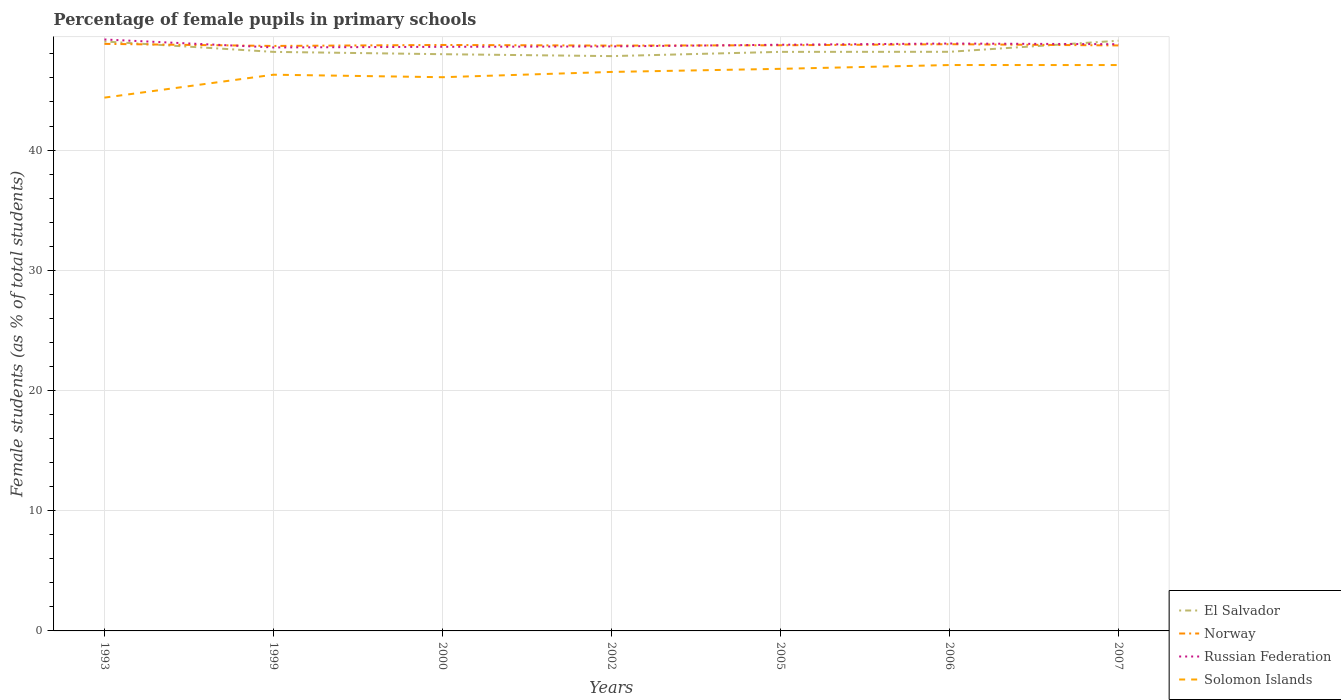How many different coloured lines are there?
Provide a short and direct response. 4. Is the number of lines equal to the number of legend labels?
Keep it short and to the point. Yes. Across all years, what is the maximum percentage of female pupils in primary schools in Norway?
Provide a short and direct response. 48.66. What is the total percentage of female pupils in primary schools in El Salvador in the graph?
Ensure brevity in your answer.  -0.93. What is the difference between the highest and the second highest percentage of female pupils in primary schools in Russian Federation?
Make the answer very short. 0.66. What is the difference between the highest and the lowest percentage of female pupils in primary schools in Norway?
Offer a very short reply. 3. Is the percentage of female pupils in primary schools in El Salvador strictly greater than the percentage of female pupils in primary schools in Russian Federation over the years?
Make the answer very short. No. How many years are there in the graph?
Your answer should be compact. 7. What is the difference between two consecutive major ticks on the Y-axis?
Your answer should be compact. 10. Are the values on the major ticks of Y-axis written in scientific E-notation?
Offer a very short reply. No. Does the graph contain grids?
Offer a very short reply. Yes. Where does the legend appear in the graph?
Provide a short and direct response. Bottom right. How many legend labels are there?
Offer a very short reply. 4. How are the legend labels stacked?
Your answer should be compact. Vertical. What is the title of the graph?
Offer a terse response. Percentage of female pupils in primary schools. What is the label or title of the Y-axis?
Offer a terse response. Female students (as % of total students). What is the Female students (as % of total students) in El Salvador in 1993?
Keep it short and to the point. 49.03. What is the Female students (as % of total students) in Norway in 1993?
Your answer should be compact. 48.83. What is the Female students (as % of total students) of Russian Federation in 1993?
Offer a terse response. 49.2. What is the Female students (as % of total students) of Solomon Islands in 1993?
Ensure brevity in your answer.  44.36. What is the Female students (as % of total students) of El Salvador in 1999?
Ensure brevity in your answer.  48.17. What is the Female students (as % of total students) in Norway in 1999?
Offer a terse response. 48.66. What is the Female students (as % of total students) in Russian Federation in 1999?
Keep it short and to the point. 48.54. What is the Female students (as % of total students) in Solomon Islands in 1999?
Provide a short and direct response. 46.27. What is the Female students (as % of total students) in El Salvador in 2000?
Ensure brevity in your answer.  47.97. What is the Female students (as % of total students) of Norway in 2000?
Your answer should be very brief. 48.74. What is the Female students (as % of total students) of Russian Federation in 2000?
Offer a terse response. 48.59. What is the Female students (as % of total students) in Solomon Islands in 2000?
Provide a short and direct response. 46.06. What is the Female students (as % of total students) in El Salvador in 2002?
Give a very brief answer. 47.82. What is the Female students (as % of total students) in Norway in 2002?
Provide a short and direct response. 48.69. What is the Female students (as % of total students) in Russian Federation in 2002?
Offer a terse response. 48.62. What is the Female students (as % of total students) of Solomon Islands in 2002?
Keep it short and to the point. 46.5. What is the Female students (as % of total students) of El Salvador in 2005?
Ensure brevity in your answer.  48.17. What is the Female students (as % of total students) of Norway in 2005?
Offer a terse response. 48.72. What is the Female students (as % of total students) in Russian Federation in 2005?
Your answer should be very brief. 48.76. What is the Female students (as % of total students) of Solomon Islands in 2005?
Give a very brief answer. 46.76. What is the Female students (as % of total students) in El Salvador in 2006?
Your answer should be very brief. 48.17. What is the Female students (as % of total students) of Norway in 2006?
Your answer should be compact. 48.81. What is the Female students (as % of total students) of Russian Federation in 2006?
Your response must be concise. 48.86. What is the Female students (as % of total students) of Solomon Islands in 2006?
Provide a succinct answer. 47.07. What is the Female students (as % of total students) of El Salvador in 2007?
Make the answer very short. 49.09. What is the Female students (as % of total students) of Norway in 2007?
Your answer should be very brief. 48.7. What is the Female students (as % of total students) of Russian Federation in 2007?
Offer a terse response. 48.81. What is the Female students (as % of total students) in Solomon Islands in 2007?
Your answer should be compact. 47.07. Across all years, what is the maximum Female students (as % of total students) of El Salvador?
Provide a succinct answer. 49.09. Across all years, what is the maximum Female students (as % of total students) in Norway?
Provide a short and direct response. 48.83. Across all years, what is the maximum Female students (as % of total students) of Russian Federation?
Give a very brief answer. 49.2. Across all years, what is the maximum Female students (as % of total students) in Solomon Islands?
Provide a succinct answer. 47.07. Across all years, what is the minimum Female students (as % of total students) in El Salvador?
Ensure brevity in your answer.  47.82. Across all years, what is the minimum Female students (as % of total students) of Norway?
Provide a short and direct response. 48.66. Across all years, what is the minimum Female students (as % of total students) in Russian Federation?
Give a very brief answer. 48.54. Across all years, what is the minimum Female students (as % of total students) of Solomon Islands?
Offer a very short reply. 44.36. What is the total Female students (as % of total students) in El Salvador in the graph?
Make the answer very short. 338.43. What is the total Female students (as % of total students) of Norway in the graph?
Your answer should be very brief. 341.15. What is the total Female students (as % of total students) of Russian Federation in the graph?
Provide a succinct answer. 341.38. What is the total Female students (as % of total students) of Solomon Islands in the graph?
Offer a very short reply. 324.09. What is the difference between the Female students (as % of total students) of El Salvador in 1993 and that in 1999?
Provide a short and direct response. 0.86. What is the difference between the Female students (as % of total students) of Norway in 1993 and that in 1999?
Give a very brief answer. 0.17. What is the difference between the Female students (as % of total students) in Russian Federation in 1993 and that in 1999?
Provide a succinct answer. 0.66. What is the difference between the Female students (as % of total students) of Solomon Islands in 1993 and that in 1999?
Keep it short and to the point. -1.91. What is the difference between the Female students (as % of total students) of El Salvador in 1993 and that in 2000?
Offer a terse response. 1.06. What is the difference between the Female students (as % of total students) of Norway in 1993 and that in 2000?
Keep it short and to the point. 0.09. What is the difference between the Female students (as % of total students) of Russian Federation in 1993 and that in 2000?
Provide a succinct answer. 0.61. What is the difference between the Female students (as % of total students) in Solomon Islands in 1993 and that in 2000?
Offer a very short reply. -1.7. What is the difference between the Female students (as % of total students) in El Salvador in 1993 and that in 2002?
Your answer should be compact. 1.22. What is the difference between the Female students (as % of total students) in Norway in 1993 and that in 2002?
Ensure brevity in your answer.  0.14. What is the difference between the Female students (as % of total students) of Russian Federation in 1993 and that in 2002?
Your response must be concise. 0.58. What is the difference between the Female students (as % of total students) in Solomon Islands in 1993 and that in 2002?
Make the answer very short. -2.14. What is the difference between the Female students (as % of total students) of El Salvador in 1993 and that in 2005?
Offer a very short reply. 0.86. What is the difference between the Female students (as % of total students) in Norway in 1993 and that in 2005?
Offer a terse response. 0.12. What is the difference between the Female students (as % of total students) of Russian Federation in 1993 and that in 2005?
Offer a very short reply. 0.44. What is the difference between the Female students (as % of total students) in Solomon Islands in 1993 and that in 2005?
Your answer should be very brief. -2.4. What is the difference between the Female students (as % of total students) of El Salvador in 1993 and that in 2006?
Provide a short and direct response. 0.86. What is the difference between the Female students (as % of total students) of Norway in 1993 and that in 2006?
Offer a very short reply. 0.03. What is the difference between the Female students (as % of total students) of Russian Federation in 1993 and that in 2006?
Keep it short and to the point. 0.34. What is the difference between the Female students (as % of total students) of Solomon Islands in 1993 and that in 2006?
Provide a short and direct response. -2.71. What is the difference between the Female students (as % of total students) in El Salvador in 1993 and that in 2007?
Give a very brief answer. -0.06. What is the difference between the Female students (as % of total students) in Norway in 1993 and that in 2007?
Your answer should be compact. 0.13. What is the difference between the Female students (as % of total students) in Russian Federation in 1993 and that in 2007?
Your answer should be compact. 0.39. What is the difference between the Female students (as % of total students) in Solomon Islands in 1993 and that in 2007?
Your answer should be compact. -2.71. What is the difference between the Female students (as % of total students) of El Salvador in 1999 and that in 2000?
Your answer should be compact. 0.19. What is the difference between the Female students (as % of total students) in Norway in 1999 and that in 2000?
Make the answer very short. -0.08. What is the difference between the Female students (as % of total students) in Russian Federation in 1999 and that in 2000?
Your answer should be very brief. -0.05. What is the difference between the Female students (as % of total students) in Solomon Islands in 1999 and that in 2000?
Your response must be concise. 0.21. What is the difference between the Female students (as % of total students) in El Salvador in 1999 and that in 2002?
Your response must be concise. 0.35. What is the difference between the Female students (as % of total students) in Norway in 1999 and that in 2002?
Your response must be concise. -0.03. What is the difference between the Female students (as % of total students) of Russian Federation in 1999 and that in 2002?
Offer a terse response. -0.09. What is the difference between the Female students (as % of total students) of Solomon Islands in 1999 and that in 2002?
Keep it short and to the point. -0.23. What is the difference between the Female students (as % of total students) in El Salvador in 1999 and that in 2005?
Offer a terse response. -0. What is the difference between the Female students (as % of total students) in Norway in 1999 and that in 2005?
Make the answer very short. -0.05. What is the difference between the Female students (as % of total students) in Russian Federation in 1999 and that in 2005?
Provide a short and direct response. -0.22. What is the difference between the Female students (as % of total students) in Solomon Islands in 1999 and that in 2005?
Your answer should be compact. -0.49. What is the difference between the Female students (as % of total students) of El Salvador in 1999 and that in 2006?
Keep it short and to the point. -0.01. What is the difference between the Female students (as % of total students) in Norway in 1999 and that in 2006?
Provide a short and direct response. -0.14. What is the difference between the Female students (as % of total students) of Russian Federation in 1999 and that in 2006?
Provide a succinct answer. -0.33. What is the difference between the Female students (as % of total students) in Solomon Islands in 1999 and that in 2006?
Your answer should be very brief. -0.8. What is the difference between the Female students (as % of total students) of El Salvador in 1999 and that in 2007?
Your answer should be compact. -0.93. What is the difference between the Female students (as % of total students) in Norway in 1999 and that in 2007?
Your answer should be compact. -0.04. What is the difference between the Female students (as % of total students) of Russian Federation in 1999 and that in 2007?
Your answer should be compact. -0.27. What is the difference between the Female students (as % of total students) in Solomon Islands in 1999 and that in 2007?
Your answer should be very brief. -0.8. What is the difference between the Female students (as % of total students) of El Salvador in 2000 and that in 2002?
Ensure brevity in your answer.  0.16. What is the difference between the Female students (as % of total students) of Norway in 2000 and that in 2002?
Give a very brief answer. 0.05. What is the difference between the Female students (as % of total students) in Russian Federation in 2000 and that in 2002?
Offer a very short reply. -0.03. What is the difference between the Female students (as % of total students) of Solomon Islands in 2000 and that in 2002?
Provide a short and direct response. -0.44. What is the difference between the Female students (as % of total students) in El Salvador in 2000 and that in 2005?
Make the answer very short. -0.19. What is the difference between the Female students (as % of total students) of Norway in 2000 and that in 2005?
Give a very brief answer. 0.03. What is the difference between the Female students (as % of total students) of Russian Federation in 2000 and that in 2005?
Your response must be concise. -0.17. What is the difference between the Female students (as % of total students) in Solomon Islands in 2000 and that in 2005?
Offer a terse response. -0.7. What is the difference between the Female students (as % of total students) in El Salvador in 2000 and that in 2006?
Give a very brief answer. -0.2. What is the difference between the Female students (as % of total students) in Norway in 2000 and that in 2006?
Make the answer very short. -0.06. What is the difference between the Female students (as % of total students) of Russian Federation in 2000 and that in 2006?
Offer a very short reply. -0.27. What is the difference between the Female students (as % of total students) in Solomon Islands in 2000 and that in 2006?
Offer a very short reply. -1.01. What is the difference between the Female students (as % of total students) in El Salvador in 2000 and that in 2007?
Ensure brevity in your answer.  -1.12. What is the difference between the Female students (as % of total students) in Norway in 2000 and that in 2007?
Make the answer very short. 0.04. What is the difference between the Female students (as % of total students) of Russian Federation in 2000 and that in 2007?
Provide a short and direct response. -0.22. What is the difference between the Female students (as % of total students) of Solomon Islands in 2000 and that in 2007?
Provide a short and direct response. -1.01. What is the difference between the Female students (as % of total students) in El Salvador in 2002 and that in 2005?
Your answer should be very brief. -0.35. What is the difference between the Female students (as % of total students) in Norway in 2002 and that in 2005?
Your response must be concise. -0.03. What is the difference between the Female students (as % of total students) in Russian Federation in 2002 and that in 2005?
Your answer should be very brief. -0.14. What is the difference between the Female students (as % of total students) of Solomon Islands in 2002 and that in 2005?
Give a very brief answer. -0.26. What is the difference between the Female students (as % of total students) in El Salvador in 2002 and that in 2006?
Offer a very short reply. -0.36. What is the difference between the Female students (as % of total students) in Norway in 2002 and that in 2006?
Provide a short and direct response. -0.11. What is the difference between the Female students (as % of total students) in Russian Federation in 2002 and that in 2006?
Make the answer very short. -0.24. What is the difference between the Female students (as % of total students) of Solomon Islands in 2002 and that in 2006?
Your answer should be compact. -0.57. What is the difference between the Female students (as % of total students) in El Salvador in 2002 and that in 2007?
Your answer should be compact. -1.28. What is the difference between the Female students (as % of total students) in Norway in 2002 and that in 2007?
Keep it short and to the point. -0.01. What is the difference between the Female students (as % of total students) in Russian Federation in 2002 and that in 2007?
Offer a terse response. -0.18. What is the difference between the Female students (as % of total students) of Solomon Islands in 2002 and that in 2007?
Provide a short and direct response. -0.57. What is the difference between the Female students (as % of total students) in El Salvador in 2005 and that in 2006?
Provide a succinct answer. -0. What is the difference between the Female students (as % of total students) in Norway in 2005 and that in 2006?
Give a very brief answer. -0.09. What is the difference between the Female students (as % of total students) of Russian Federation in 2005 and that in 2006?
Give a very brief answer. -0.1. What is the difference between the Female students (as % of total students) in Solomon Islands in 2005 and that in 2006?
Offer a very short reply. -0.32. What is the difference between the Female students (as % of total students) in El Salvador in 2005 and that in 2007?
Your answer should be very brief. -0.93. What is the difference between the Female students (as % of total students) of Norway in 2005 and that in 2007?
Make the answer very short. 0.01. What is the difference between the Female students (as % of total students) in Russian Federation in 2005 and that in 2007?
Make the answer very short. -0.05. What is the difference between the Female students (as % of total students) of Solomon Islands in 2005 and that in 2007?
Your answer should be very brief. -0.32. What is the difference between the Female students (as % of total students) in El Salvador in 2006 and that in 2007?
Offer a very short reply. -0.92. What is the difference between the Female students (as % of total students) of Norway in 2006 and that in 2007?
Your answer should be compact. 0.1. What is the difference between the Female students (as % of total students) in Russian Federation in 2006 and that in 2007?
Offer a terse response. 0.06. What is the difference between the Female students (as % of total students) in Solomon Islands in 2006 and that in 2007?
Offer a terse response. 0. What is the difference between the Female students (as % of total students) in El Salvador in 1993 and the Female students (as % of total students) in Norway in 1999?
Offer a very short reply. 0.37. What is the difference between the Female students (as % of total students) of El Salvador in 1993 and the Female students (as % of total students) of Russian Federation in 1999?
Provide a short and direct response. 0.5. What is the difference between the Female students (as % of total students) of El Salvador in 1993 and the Female students (as % of total students) of Solomon Islands in 1999?
Offer a terse response. 2.76. What is the difference between the Female students (as % of total students) of Norway in 1993 and the Female students (as % of total students) of Russian Federation in 1999?
Keep it short and to the point. 0.3. What is the difference between the Female students (as % of total students) in Norway in 1993 and the Female students (as % of total students) in Solomon Islands in 1999?
Make the answer very short. 2.57. What is the difference between the Female students (as % of total students) of Russian Federation in 1993 and the Female students (as % of total students) of Solomon Islands in 1999?
Offer a terse response. 2.93. What is the difference between the Female students (as % of total students) of El Salvador in 1993 and the Female students (as % of total students) of Norway in 2000?
Your answer should be compact. 0.29. What is the difference between the Female students (as % of total students) in El Salvador in 1993 and the Female students (as % of total students) in Russian Federation in 2000?
Your answer should be compact. 0.44. What is the difference between the Female students (as % of total students) of El Salvador in 1993 and the Female students (as % of total students) of Solomon Islands in 2000?
Your answer should be compact. 2.97. What is the difference between the Female students (as % of total students) in Norway in 1993 and the Female students (as % of total students) in Russian Federation in 2000?
Provide a short and direct response. 0.24. What is the difference between the Female students (as % of total students) of Norway in 1993 and the Female students (as % of total students) of Solomon Islands in 2000?
Give a very brief answer. 2.77. What is the difference between the Female students (as % of total students) of Russian Federation in 1993 and the Female students (as % of total students) of Solomon Islands in 2000?
Your answer should be compact. 3.14. What is the difference between the Female students (as % of total students) in El Salvador in 1993 and the Female students (as % of total students) in Norway in 2002?
Offer a terse response. 0.34. What is the difference between the Female students (as % of total students) in El Salvador in 1993 and the Female students (as % of total students) in Russian Federation in 2002?
Your answer should be very brief. 0.41. What is the difference between the Female students (as % of total students) in El Salvador in 1993 and the Female students (as % of total students) in Solomon Islands in 2002?
Your response must be concise. 2.53. What is the difference between the Female students (as % of total students) of Norway in 1993 and the Female students (as % of total students) of Russian Federation in 2002?
Ensure brevity in your answer.  0.21. What is the difference between the Female students (as % of total students) of Norway in 1993 and the Female students (as % of total students) of Solomon Islands in 2002?
Ensure brevity in your answer.  2.33. What is the difference between the Female students (as % of total students) of Russian Federation in 1993 and the Female students (as % of total students) of Solomon Islands in 2002?
Make the answer very short. 2.7. What is the difference between the Female students (as % of total students) in El Salvador in 1993 and the Female students (as % of total students) in Norway in 2005?
Provide a short and direct response. 0.32. What is the difference between the Female students (as % of total students) of El Salvador in 1993 and the Female students (as % of total students) of Russian Federation in 2005?
Make the answer very short. 0.27. What is the difference between the Female students (as % of total students) in El Salvador in 1993 and the Female students (as % of total students) in Solomon Islands in 2005?
Provide a succinct answer. 2.27. What is the difference between the Female students (as % of total students) in Norway in 1993 and the Female students (as % of total students) in Russian Federation in 2005?
Your answer should be very brief. 0.07. What is the difference between the Female students (as % of total students) in Norway in 1993 and the Female students (as % of total students) in Solomon Islands in 2005?
Give a very brief answer. 2.08. What is the difference between the Female students (as % of total students) in Russian Federation in 1993 and the Female students (as % of total students) in Solomon Islands in 2005?
Your answer should be very brief. 2.44. What is the difference between the Female students (as % of total students) in El Salvador in 1993 and the Female students (as % of total students) in Norway in 2006?
Provide a succinct answer. 0.23. What is the difference between the Female students (as % of total students) in El Salvador in 1993 and the Female students (as % of total students) in Russian Federation in 2006?
Provide a succinct answer. 0.17. What is the difference between the Female students (as % of total students) of El Salvador in 1993 and the Female students (as % of total students) of Solomon Islands in 2006?
Your answer should be very brief. 1.96. What is the difference between the Female students (as % of total students) in Norway in 1993 and the Female students (as % of total students) in Russian Federation in 2006?
Provide a succinct answer. -0.03. What is the difference between the Female students (as % of total students) of Norway in 1993 and the Female students (as % of total students) of Solomon Islands in 2006?
Your response must be concise. 1.76. What is the difference between the Female students (as % of total students) of Russian Federation in 1993 and the Female students (as % of total students) of Solomon Islands in 2006?
Offer a very short reply. 2.13. What is the difference between the Female students (as % of total students) of El Salvador in 1993 and the Female students (as % of total students) of Norway in 2007?
Provide a succinct answer. 0.33. What is the difference between the Female students (as % of total students) in El Salvador in 1993 and the Female students (as % of total students) in Russian Federation in 2007?
Give a very brief answer. 0.23. What is the difference between the Female students (as % of total students) of El Salvador in 1993 and the Female students (as % of total students) of Solomon Islands in 2007?
Give a very brief answer. 1.96. What is the difference between the Female students (as % of total students) in Norway in 1993 and the Female students (as % of total students) in Russian Federation in 2007?
Your answer should be very brief. 0.03. What is the difference between the Female students (as % of total students) of Norway in 1993 and the Female students (as % of total students) of Solomon Islands in 2007?
Your answer should be very brief. 1.76. What is the difference between the Female students (as % of total students) in Russian Federation in 1993 and the Female students (as % of total students) in Solomon Islands in 2007?
Give a very brief answer. 2.13. What is the difference between the Female students (as % of total students) in El Salvador in 1999 and the Female students (as % of total students) in Norway in 2000?
Your answer should be very brief. -0.58. What is the difference between the Female students (as % of total students) of El Salvador in 1999 and the Female students (as % of total students) of Russian Federation in 2000?
Ensure brevity in your answer.  -0.42. What is the difference between the Female students (as % of total students) in El Salvador in 1999 and the Female students (as % of total students) in Solomon Islands in 2000?
Offer a terse response. 2.11. What is the difference between the Female students (as % of total students) of Norway in 1999 and the Female students (as % of total students) of Russian Federation in 2000?
Offer a very short reply. 0.07. What is the difference between the Female students (as % of total students) in Norway in 1999 and the Female students (as % of total students) in Solomon Islands in 2000?
Give a very brief answer. 2.6. What is the difference between the Female students (as % of total students) of Russian Federation in 1999 and the Female students (as % of total students) of Solomon Islands in 2000?
Give a very brief answer. 2.48. What is the difference between the Female students (as % of total students) in El Salvador in 1999 and the Female students (as % of total students) in Norway in 2002?
Offer a terse response. -0.52. What is the difference between the Female students (as % of total students) in El Salvador in 1999 and the Female students (as % of total students) in Russian Federation in 2002?
Your response must be concise. -0.45. What is the difference between the Female students (as % of total students) in El Salvador in 1999 and the Female students (as % of total students) in Solomon Islands in 2002?
Provide a short and direct response. 1.67. What is the difference between the Female students (as % of total students) of Norway in 1999 and the Female students (as % of total students) of Russian Federation in 2002?
Keep it short and to the point. 0.04. What is the difference between the Female students (as % of total students) of Norway in 1999 and the Female students (as % of total students) of Solomon Islands in 2002?
Offer a very short reply. 2.16. What is the difference between the Female students (as % of total students) in Russian Federation in 1999 and the Female students (as % of total students) in Solomon Islands in 2002?
Offer a terse response. 2.04. What is the difference between the Female students (as % of total students) in El Salvador in 1999 and the Female students (as % of total students) in Norway in 2005?
Keep it short and to the point. -0.55. What is the difference between the Female students (as % of total students) of El Salvador in 1999 and the Female students (as % of total students) of Russian Federation in 2005?
Offer a very short reply. -0.59. What is the difference between the Female students (as % of total students) in El Salvador in 1999 and the Female students (as % of total students) in Solomon Islands in 2005?
Your answer should be compact. 1.41. What is the difference between the Female students (as % of total students) in Norway in 1999 and the Female students (as % of total students) in Russian Federation in 2005?
Your answer should be compact. -0.1. What is the difference between the Female students (as % of total students) in Norway in 1999 and the Female students (as % of total students) in Solomon Islands in 2005?
Offer a terse response. 1.9. What is the difference between the Female students (as % of total students) of Russian Federation in 1999 and the Female students (as % of total students) of Solomon Islands in 2005?
Your answer should be compact. 1.78. What is the difference between the Female students (as % of total students) in El Salvador in 1999 and the Female students (as % of total students) in Norway in 2006?
Your answer should be very brief. -0.64. What is the difference between the Female students (as % of total students) in El Salvador in 1999 and the Female students (as % of total students) in Russian Federation in 2006?
Offer a very short reply. -0.69. What is the difference between the Female students (as % of total students) in El Salvador in 1999 and the Female students (as % of total students) in Solomon Islands in 2006?
Your answer should be compact. 1.09. What is the difference between the Female students (as % of total students) of Norway in 1999 and the Female students (as % of total students) of Russian Federation in 2006?
Your answer should be compact. -0.2. What is the difference between the Female students (as % of total students) in Norway in 1999 and the Female students (as % of total students) in Solomon Islands in 2006?
Your answer should be compact. 1.59. What is the difference between the Female students (as % of total students) in Russian Federation in 1999 and the Female students (as % of total students) in Solomon Islands in 2006?
Give a very brief answer. 1.46. What is the difference between the Female students (as % of total students) in El Salvador in 1999 and the Female students (as % of total students) in Norway in 2007?
Offer a terse response. -0.54. What is the difference between the Female students (as % of total students) of El Salvador in 1999 and the Female students (as % of total students) of Russian Federation in 2007?
Offer a terse response. -0.64. What is the difference between the Female students (as % of total students) of El Salvador in 1999 and the Female students (as % of total students) of Solomon Islands in 2007?
Keep it short and to the point. 1.1. What is the difference between the Female students (as % of total students) in Norway in 1999 and the Female students (as % of total students) in Russian Federation in 2007?
Keep it short and to the point. -0.14. What is the difference between the Female students (as % of total students) of Norway in 1999 and the Female students (as % of total students) of Solomon Islands in 2007?
Provide a succinct answer. 1.59. What is the difference between the Female students (as % of total students) in Russian Federation in 1999 and the Female students (as % of total students) in Solomon Islands in 2007?
Your answer should be compact. 1.46. What is the difference between the Female students (as % of total students) of El Salvador in 2000 and the Female students (as % of total students) of Norway in 2002?
Your answer should be very brief. -0.72. What is the difference between the Female students (as % of total students) of El Salvador in 2000 and the Female students (as % of total students) of Russian Federation in 2002?
Keep it short and to the point. -0.65. What is the difference between the Female students (as % of total students) in El Salvador in 2000 and the Female students (as % of total students) in Solomon Islands in 2002?
Your answer should be compact. 1.47. What is the difference between the Female students (as % of total students) in Norway in 2000 and the Female students (as % of total students) in Russian Federation in 2002?
Provide a succinct answer. 0.12. What is the difference between the Female students (as % of total students) of Norway in 2000 and the Female students (as % of total students) of Solomon Islands in 2002?
Provide a short and direct response. 2.24. What is the difference between the Female students (as % of total students) of Russian Federation in 2000 and the Female students (as % of total students) of Solomon Islands in 2002?
Make the answer very short. 2.09. What is the difference between the Female students (as % of total students) in El Salvador in 2000 and the Female students (as % of total students) in Norway in 2005?
Your answer should be very brief. -0.74. What is the difference between the Female students (as % of total students) of El Salvador in 2000 and the Female students (as % of total students) of Russian Federation in 2005?
Offer a terse response. -0.79. What is the difference between the Female students (as % of total students) of El Salvador in 2000 and the Female students (as % of total students) of Solomon Islands in 2005?
Your answer should be very brief. 1.22. What is the difference between the Female students (as % of total students) of Norway in 2000 and the Female students (as % of total students) of Russian Federation in 2005?
Ensure brevity in your answer.  -0.02. What is the difference between the Female students (as % of total students) in Norway in 2000 and the Female students (as % of total students) in Solomon Islands in 2005?
Ensure brevity in your answer.  1.99. What is the difference between the Female students (as % of total students) in Russian Federation in 2000 and the Female students (as % of total students) in Solomon Islands in 2005?
Provide a short and direct response. 1.83. What is the difference between the Female students (as % of total students) of El Salvador in 2000 and the Female students (as % of total students) of Norway in 2006?
Give a very brief answer. -0.83. What is the difference between the Female students (as % of total students) in El Salvador in 2000 and the Female students (as % of total students) in Russian Federation in 2006?
Your response must be concise. -0.89. What is the difference between the Female students (as % of total students) in El Salvador in 2000 and the Female students (as % of total students) in Solomon Islands in 2006?
Keep it short and to the point. 0.9. What is the difference between the Female students (as % of total students) in Norway in 2000 and the Female students (as % of total students) in Russian Federation in 2006?
Give a very brief answer. -0.12. What is the difference between the Female students (as % of total students) in Norway in 2000 and the Female students (as % of total students) in Solomon Islands in 2006?
Make the answer very short. 1.67. What is the difference between the Female students (as % of total students) of Russian Federation in 2000 and the Female students (as % of total students) of Solomon Islands in 2006?
Your answer should be very brief. 1.52. What is the difference between the Female students (as % of total students) of El Salvador in 2000 and the Female students (as % of total students) of Norway in 2007?
Make the answer very short. -0.73. What is the difference between the Female students (as % of total students) of El Salvador in 2000 and the Female students (as % of total students) of Russian Federation in 2007?
Offer a very short reply. -0.83. What is the difference between the Female students (as % of total students) of El Salvador in 2000 and the Female students (as % of total students) of Solomon Islands in 2007?
Ensure brevity in your answer.  0.9. What is the difference between the Female students (as % of total students) of Norway in 2000 and the Female students (as % of total students) of Russian Federation in 2007?
Give a very brief answer. -0.06. What is the difference between the Female students (as % of total students) in Norway in 2000 and the Female students (as % of total students) in Solomon Islands in 2007?
Make the answer very short. 1.67. What is the difference between the Female students (as % of total students) of Russian Federation in 2000 and the Female students (as % of total students) of Solomon Islands in 2007?
Provide a succinct answer. 1.52. What is the difference between the Female students (as % of total students) in El Salvador in 2002 and the Female students (as % of total students) in Norway in 2005?
Your answer should be very brief. -0.9. What is the difference between the Female students (as % of total students) of El Salvador in 2002 and the Female students (as % of total students) of Russian Federation in 2005?
Make the answer very short. -0.95. What is the difference between the Female students (as % of total students) of El Salvador in 2002 and the Female students (as % of total students) of Solomon Islands in 2005?
Offer a very short reply. 1.06. What is the difference between the Female students (as % of total students) in Norway in 2002 and the Female students (as % of total students) in Russian Federation in 2005?
Provide a short and direct response. -0.07. What is the difference between the Female students (as % of total students) in Norway in 2002 and the Female students (as % of total students) in Solomon Islands in 2005?
Make the answer very short. 1.93. What is the difference between the Female students (as % of total students) in Russian Federation in 2002 and the Female students (as % of total students) in Solomon Islands in 2005?
Your answer should be compact. 1.86. What is the difference between the Female students (as % of total students) in El Salvador in 2002 and the Female students (as % of total students) in Norway in 2006?
Provide a succinct answer. -0.99. What is the difference between the Female students (as % of total students) of El Salvador in 2002 and the Female students (as % of total students) of Russian Federation in 2006?
Your response must be concise. -1.05. What is the difference between the Female students (as % of total students) in El Salvador in 2002 and the Female students (as % of total students) in Solomon Islands in 2006?
Your response must be concise. 0.74. What is the difference between the Female students (as % of total students) in Norway in 2002 and the Female students (as % of total students) in Russian Federation in 2006?
Offer a very short reply. -0.17. What is the difference between the Female students (as % of total students) in Norway in 2002 and the Female students (as % of total students) in Solomon Islands in 2006?
Keep it short and to the point. 1.62. What is the difference between the Female students (as % of total students) of Russian Federation in 2002 and the Female students (as % of total students) of Solomon Islands in 2006?
Offer a terse response. 1.55. What is the difference between the Female students (as % of total students) in El Salvador in 2002 and the Female students (as % of total students) in Norway in 2007?
Your response must be concise. -0.89. What is the difference between the Female students (as % of total students) in El Salvador in 2002 and the Female students (as % of total students) in Russian Federation in 2007?
Keep it short and to the point. -0.99. What is the difference between the Female students (as % of total students) in El Salvador in 2002 and the Female students (as % of total students) in Solomon Islands in 2007?
Offer a very short reply. 0.74. What is the difference between the Female students (as % of total students) in Norway in 2002 and the Female students (as % of total students) in Russian Federation in 2007?
Provide a short and direct response. -0.12. What is the difference between the Female students (as % of total students) in Norway in 2002 and the Female students (as % of total students) in Solomon Islands in 2007?
Your answer should be compact. 1.62. What is the difference between the Female students (as % of total students) of Russian Federation in 2002 and the Female students (as % of total students) of Solomon Islands in 2007?
Your answer should be very brief. 1.55. What is the difference between the Female students (as % of total students) of El Salvador in 2005 and the Female students (as % of total students) of Norway in 2006?
Give a very brief answer. -0.64. What is the difference between the Female students (as % of total students) in El Salvador in 2005 and the Female students (as % of total students) in Russian Federation in 2006?
Your answer should be compact. -0.69. What is the difference between the Female students (as % of total students) of El Salvador in 2005 and the Female students (as % of total students) of Solomon Islands in 2006?
Offer a terse response. 1.1. What is the difference between the Female students (as % of total students) of Norway in 2005 and the Female students (as % of total students) of Russian Federation in 2006?
Ensure brevity in your answer.  -0.15. What is the difference between the Female students (as % of total students) of Norway in 2005 and the Female students (as % of total students) of Solomon Islands in 2006?
Your response must be concise. 1.64. What is the difference between the Female students (as % of total students) of Russian Federation in 2005 and the Female students (as % of total students) of Solomon Islands in 2006?
Provide a succinct answer. 1.69. What is the difference between the Female students (as % of total students) of El Salvador in 2005 and the Female students (as % of total students) of Norway in 2007?
Provide a short and direct response. -0.53. What is the difference between the Female students (as % of total students) in El Salvador in 2005 and the Female students (as % of total students) in Russian Federation in 2007?
Keep it short and to the point. -0.64. What is the difference between the Female students (as % of total students) in El Salvador in 2005 and the Female students (as % of total students) in Solomon Islands in 2007?
Your response must be concise. 1.1. What is the difference between the Female students (as % of total students) in Norway in 2005 and the Female students (as % of total students) in Russian Federation in 2007?
Give a very brief answer. -0.09. What is the difference between the Female students (as % of total students) of Norway in 2005 and the Female students (as % of total students) of Solomon Islands in 2007?
Provide a succinct answer. 1.64. What is the difference between the Female students (as % of total students) in Russian Federation in 2005 and the Female students (as % of total students) in Solomon Islands in 2007?
Provide a succinct answer. 1.69. What is the difference between the Female students (as % of total students) in El Salvador in 2006 and the Female students (as % of total students) in Norway in 2007?
Offer a very short reply. -0.53. What is the difference between the Female students (as % of total students) of El Salvador in 2006 and the Female students (as % of total students) of Russian Federation in 2007?
Offer a very short reply. -0.63. What is the difference between the Female students (as % of total students) in El Salvador in 2006 and the Female students (as % of total students) in Solomon Islands in 2007?
Keep it short and to the point. 1.1. What is the difference between the Female students (as % of total students) of Norway in 2006 and the Female students (as % of total students) of Russian Federation in 2007?
Your response must be concise. -0. What is the difference between the Female students (as % of total students) of Norway in 2006 and the Female students (as % of total students) of Solomon Islands in 2007?
Make the answer very short. 1.73. What is the difference between the Female students (as % of total students) of Russian Federation in 2006 and the Female students (as % of total students) of Solomon Islands in 2007?
Offer a terse response. 1.79. What is the average Female students (as % of total students) of El Salvador per year?
Provide a short and direct response. 48.35. What is the average Female students (as % of total students) of Norway per year?
Keep it short and to the point. 48.74. What is the average Female students (as % of total students) of Russian Federation per year?
Offer a very short reply. 48.77. What is the average Female students (as % of total students) in Solomon Islands per year?
Your answer should be very brief. 46.3. In the year 1993, what is the difference between the Female students (as % of total students) in El Salvador and Female students (as % of total students) in Norway?
Your answer should be very brief. 0.2. In the year 1993, what is the difference between the Female students (as % of total students) in El Salvador and Female students (as % of total students) in Russian Federation?
Your answer should be very brief. -0.17. In the year 1993, what is the difference between the Female students (as % of total students) in El Salvador and Female students (as % of total students) in Solomon Islands?
Your answer should be very brief. 4.67. In the year 1993, what is the difference between the Female students (as % of total students) of Norway and Female students (as % of total students) of Russian Federation?
Your response must be concise. -0.36. In the year 1993, what is the difference between the Female students (as % of total students) of Norway and Female students (as % of total students) of Solomon Islands?
Give a very brief answer. 4.47. In the year 1993, what is the difference between the Female students (as % of total students) in Russian Federation and Female students (as % of total students) in Solomon Islands?
Offer a very short reply. 4.84. In the year 1999, what is the difference between the Female students (as % of total students) in El Salvador and Female students (as % of total students) in Norway?
Your answer should be very brief. -0.49. In the year 1999, what is the difference between the Female students (as % of total students) in El Salvador and Female students (as % of total students) in Russian Federation?
Your response must be concise. -0.37. In the year 1999, what is the difference between the Female students (as % of total students) in El Salvador and Female students (as % of total students) in Solomon Islands?
Keep it short and to the point. 1.9. In the year 1999, what is the difference between the Female students (as % of total students) of Norway and Female students (as % of total students) of Russian Federation?
Keep it short and to the point. 0.13. In the year 1999, what is the difference between the Female students (as % of total students) of Norway and Female students (as % of total students) of Solomon Islands?
Your response must be concise. 2.39. In the year 1999, what is the difference between the Female students (as % of total students) in Russian Federation and Female students (as % of total students) in Solomon Islands?
Offer a terse response. 2.27. In the year 2000, what is the difference between the Female students (as % of total students) in El Salvador and Female students (as % of total students) in Norway?
Offer a terse response. -0.77. In the year 2000, what is the difference between the Female students (as % of total students) in El Salvador and Female students (as % of total students) in Russian Federation?
Provide a short and direct response. -0.62. In the year 2000, what is the difference between the Female students (as % of total students) in El Salvador and Female students (as % of total students) in Solomon Islands?
Your answer should be compact. 1.91. In the year 2000, what is the difference between the Female students (as % of total students) of Norway and Female students (as % of total students) of Russian Federation?
Provide a succinct answer. 0.15. In the year 2000, what is the difference between the Female students (as % of total students) in Norway and Female students (as % of total students) in Solomon Islands?
Offer a very short reply. 2.68. In the year 2000, what is the difference between the Female students (as % of total students) of Russian Federation and Female students (as % of total students) of Solomon Islands?
Make the answer very short. 2.53. In the year 2002, what is the difference between the Female students (as % of total students) in El Salvador and Female students (as % of total students) in Norway?
Ensure brevity in your answer.  -0.88. In the year 2002, what is the difference between the Female students (as % of total students) of El Salvador and Female students (as % of total students) of Russian Federation?
Give a very brief answer. -0.81. In the year 2002, what is the difference between the Female students (as % of total students) in El Salvador and Female students (as % of total students) in Solomon Islands?
Keep it short and to the point. 1.32. In the year 2002, what is the difference between the Female students (as % of total students) of Norway and Female students (as % of total students) of Russian Federation?
Provide a succinct answer. 0.07. In the year 2002, what is the difference between the Female students (as % of total students) in Norway and Female students (as % of total students) in Solomon Islands?
Make the answer very short. 2.19. In the year 2002, what is the difference between the Female students (as % of total students) in Russian Federation and Female students (as % of total students) in Solomon Islands?
Offer a terse response. 2.12. In the year 2005, what is the difference between the Female students (as % of total students) in El Salvador and Female students (as % of total students) in Norway?
Offer a very short reply. -0.55. In the year 2005, what is the difference between the Female students (as % of total students) of El Salvador and Female students (as % of total students) of Russian Federation?
Keep it short and to the point. -0.59. In the year 2005, what is the difference between the Female students (as % of total students) in El Salvador and Female students (as % of total students) in Solomon Islands?
Keep it short and to the point. 1.41. In the year 2005, what is the difference between the Female students (as % of total students) of Norway and Female students (as % of total students) of Russian Federation?
Give a very brief answer. -0.04. In the year 2005, what is the difference between the Female students (as % of total students) in Norway and Female students (as % of total students) in Solomon Islands?
Your answer should be compact. 1.96. In the year 2005, what is the difference between the Female students (as % of total students) in Russian Federation and Female students (as % of total students) in Solomon Islands?
Give a very brief answer. 2. In the year 2006, what is the difference between the Female students (as % of total students) in El Salvador and Female students (as % of total students) in Norway?
Keep it short and to the point. -0.63. In the year 2006, what is the difference between the Female students (as % of total students) in El Salvador and Female students (as % of total students) in Russian Federation?
Offer a very short reply. -0.69. In the year 2006, what is the difference between the Female students (as % of total students) of El Salvador and Female students (as % of total students) of Solomon Islands?
Provide a short and direct response. 1.1. In the year 2006, what is the difference between the Female students (as % of total students) in Norway and Female students (as % of total students) in Russian Federation?
Offer a terse response. -0.06. In the year 2006, what is the difference between the Female students (as % of total students) in Norway and Female students (as % of total students) in Solomon Islands?
Provide a succinct answer. 1.73. In the year 2006, what is the difference between the Female students (as % of total students) of Russian Federation and Female students (as % of total students) of Solomon Islands?
Make the answer very short. 1.79. In the year 2007, what is the difference between the Female students (as % of total students) of El Salvador and Female students (as % of total students) of Norway?
Make the answer very short. 0.39. In the year 2007, what is the difference between the Female students (as % of total students) in El Salvador and Female students (as % of total students) in Russian Federation?
Your response must be concise. 0.29. In the year 2007, what is the difference between the Female students (as % of total students) of El Salvador and Female students (as % of total students) of Solomon Islands?
Provide a succinct answer. 2.02. In the year 2007, what is the difference between the Female students (as % of total students) in Norway and Female students (as % of total students) in Russian Federation?
Make the answer very short. -0.1. In the year 2007, what is the difference between the Female students (as % of total students) of Norway and Female students (as % of total students) of Solomon Islands?
Offer a very short reply. 1.63. In the year 2007, what is the difference between the Female students (as % of total students) of Russian Federation and Female students (as % of total students) of Solomon Islands?
Offer a very short reply. 1.73. What is the ratio of the Female students (as % of total students) of Norway in 1993 to that in 1999?
Provide a succinct answer. 1. What is the ratio of the Female students (as % of total students) in Russian Federation in 1993 to that in 1999?
Give a very brief answer. 1.01. What is the ratio of the Female students (as % of total students) of Solomon Islands in 1993 to that in 1999?
Your answer should be compact. 0.96. What is the ratio of the Female students (as % of total students) in El Salvador in 1993 to that in 2000?
Offer a terse response. 1.02. What is the ratio of the Female students (as % of total students) of Russian Federation in 1993 to that in 2000?
Your answer should be compact. 1.01. What is the ratio of the Female students (as % of total students) of Solomon Islands in 1993 to that in 2000?
Offer a very short reply. 0.96. What is the ratio of the Female students (as % of total students) in El Salvador in 1993 to that in 2002?
Provide a short and direct response. 1.03. What is the ratio of the Female students (as % of total students) in Russian Federation in 1993 to that in 2002?
Provide a short and direct response. 1.01. What is the ratio of the Female students (as % of total students) of Solomon Islands in 1993 to that in 2002?
Offer a very short reply. 0.95. What is the ratio of the Female students (as % of total students) of El Salvador in 1993 to that in 2005?
Offer a terse response. 1.02. What is the ratio of the Female students (as % of total students) of Russian Federation in 1993 to that in 2005?
Offer a very short reply. 1.01. What is the ratio of the Female students (as % of total students) in Solomon Islands in 1993 to that in 2005?
Offer a very short reply. 0.95. What is the ratio of the Female students (as % of total students) of El Salvador in 1993 to that in 2006?
Offer a very short reply. 1.02. What is the ratio of the Female students (as % of total students) in Solomon Islands in 1993 to that in 2006?
Keep it short and to the point. 0.94. What is the ratio of the Female students (as % of total students) of Russian Federation in 1993 to that in 2007?
Provide a succinct answer. 1.01. What is the ratio of the Female students (as % of total students) of Solomon Islands in 1993 to that in 2007?
Make the answer very short. 0.94. What is the ratio of the Female students (as % of total students) in Norway in 1999 to that in 2000?
Keep it short and to the point. 1. What is the ratio of the Female students (as % of total students) in Solomon Islands in 1999 to that in 2000?
Provide a short and direct response. 1. What is the ratio of the Female students (as % of total students) of El Salvador in 1999 to that in 2002?
Your response must be concise. 1.01. What is the ratio of the Female students (as % of total students) in Norway in 1999 to that in 2002?
Keep it short and to the point. 1. What is the ratio of the Female students (as % of total students) in Solomon Islands in 1999 to that in 2002?
Provide a succinct answer. 0.99. What is the ratio of the Female students (as % of total students) of El Salvador in 1999 to that in 2005?
Your response must be concise. 1. What is the ratio of the Female students (as % of total students) of Russian Federation in 1999 to that in 2005?
Provide a short and direct response. 1. What is the ratio of the Female students (as % of total students) in Solomon Islands in 1999 to that in 2005?
Give a very brief answer. 0.99. What is the ratio of the Female students (as % of total students) in El Salvador in 1999 to that in 2006?
Offer a terse response. 1. What is the ratio of the Female students (as % of total students) in Norway in 1999 to that in 2006?
Keep it short and to the point. 1. What is the ratio of the Female students (as % of total students) in Solomon Islands in 1999 to that in 2006?
Your answer should be very brief. 0.98. What is the ratio of the Female students (as % of total students) of El Salvador in 1999 to that in 2007?
Your answer should be very brief. 0.98. What is the ratio of the Female students (as % of total students) of Solomon Islands in 1999 to that in 2007?
Ensure brevity in your answer.  0.98. What is the ratio of the Female students (as % of total students) in Norway in 2000 to that in 2002?
Make the answer very short. 1. What is the ratio of the Female students (as % of total students) of Solomon Islands in 2000 to that in 2002?
Offer a terse response. 0.99. What is the ratio of the Female students (as % of total students) of El Salvador in 2000 to that in 2005?
Make the answer very short. 1. What is the ratio of the Female students (as % of total students) of Norway in 2000 to that in 2005?
Offer a terse response. 1. What is the ratio of the Female students (as % of total students) of Russian Federation in 2000 to that in 2005?
Your response must be concise. 1. What is the ratio of the Female students (as % of total students) of Solomon Islands in 2000 to that in 2005?
Keep it short and to the point. 0.99. What is the ratio of the Female students (as % of total students) in El Salvador in 2000 to that in 2006?
Provide a short and direct response. 1. What is the ratio of the Female students (as % of total students) in Solomon Islands in 2000 to that in 2006?
Provide a short and direct response. 0.98. What is the ratio of the Female students (as % of total students) of El Salvador in 2000 to that in 2007?
Keep it short and to the point. 0.98. What is the ratio of the Female students (as % of total students) of Norway in 2000 to that in 2007?
Offer a terse response. 1. What is the ratio of the Female students (as % of total students) in Russian Federation in 2000 to that in 2007?
Ensure brevity in your answer.  1. What is the ratio of the Female students (as % of total students) of Solomon Islands in 2000 to that in 2007?
Your response must be concise. 0.98. What is the ratio of the Female students (as % of total students) in Norway in 2002 to that in 2006?
Ensure brevity in your answer.  1. What is the ratio of the Female students (as % of total students) of Russian Federation in 2002 to that in 2006?
Ensure brevity in your answer.  1. What is the ratio of the Female students (as % of total students) in El Salvador in 2002 to that in 2007?
Offer a terse response. 0.97. What is the ratio of the Female students (as % of total students) in Norway in 2005 to that in 2006?
Offer a terse response. 1. What is the ratio of the Female students (as % of total students) in Solomon Islands in 2005 to that in 2006?
Offer a very short reply. 0.99. What is the ratio of the Female students (as % of total students) in El Salvador in 2005 to that in 2007?
Ensure brevity in your answer.  0.98. What is the ratio of the Female students (as % of total students) of Norway in 2005 to that in 2007?
Make the answer very short. 1. What is the ratio of the Female students (as % of total students) in Russian Federation in 2005 to that in 2007?
Provide a succinct answer. 1. What is the ratio of the Female students (as % of total students) of El Salvador in 2006 to that in 2007?
Your answer should be very brief. 0.98. What is the ratio of the Female students (as % of total students) of Russian Federation in 2006 to that in 2007?
Offer a very short reply. 1. What is the difference between the highest and the second highest Female students (as % of total students) in El Salvador?
Ensure brevity in your answer.  0.06. What is the difference between the highest and the second highest Female students (as % of total students) in Norway?
Give a very brief answer. 0.03. What is the difference between the highest and the second highest Female students (as % of total students) in Russian Federation?
Provide a succinct answer. 0.34. What is the difference between the highest and the second highest Female students (as % of total students) in Solomon Islands?
Make the answer very short. 0. What is the difference between the highest and the lowest Female students (as % of total students) of El Salvador?
Offer a very short reply. 1.28. What is the difference between the highest and the lowest Female students (as % of total students) in Norway?
Give a very brief answer. 0.17. What is the difference between the highest and the lowest Female students (as % of total students) of Russian Federation?
Your answer should be compact. 0.66. What is the difference between the highest and the lowest Female students (as % of total students) of Solomon Islands?
Offer a very short reply. 2.71. 